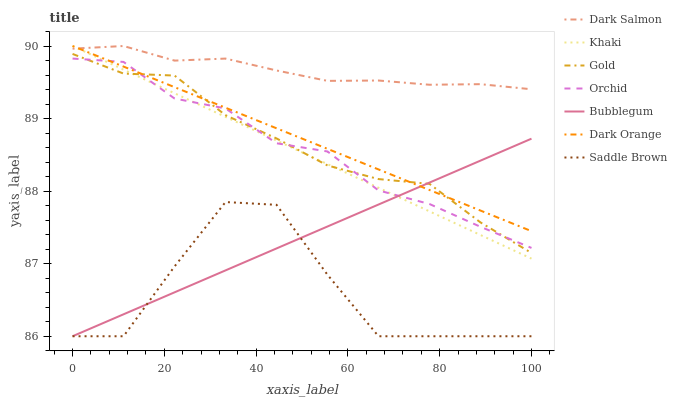Does Saddle Brown have the minimum area under the curve?
Answer yes or no. Yes. Does Dark Salmon have the maximum area under the curve?
Answer yes or no. Yes. Does Khaki have the minimum area under the curve?
Answer yes or no. No. Does Khaki have the maximum area under the curve?
Answer yes or no. No. Is Dark Orange the smoothest?
Answer yes or no. Yes. Is Saddle Brown the roughest?
Answer yes or no. Yes. Is Khaki the smoothest?
Answer yes or no. No. Is Khaki the roughest?
Answer yes or no. No. Does Bubblegum have the lowest value?
Answer yes or no. Yes. Does Khaki have the lowest value?
Answer yes or no. No. Does Dark Salmon have the highest value?
Answer yes or no. Yes. Does Gold have the highest value?
Answer yes or no. No. Is Saddle Brown less than Gold?
Answer yes or no. Yes. Is Dark Salmon greater than Gold?
Answer yes or no. Yes. Does Khaki intersect Bubblegum?
Answer yes or no. Yes. Is Khaki less than Bubblegum?
Answer yes or no. No. Is Khaki greater than Bubblegum?
Answer yes or no. No. Does Saddle Brown intersect Gold?
Answer yes or no. No. 